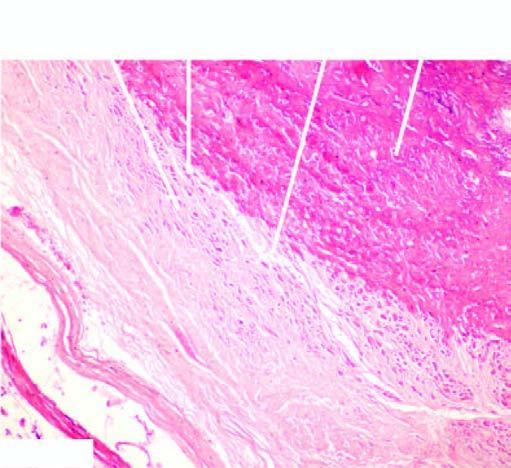what are the whorls composed of?
Answer the question using a single word or phrase. Smooth muscle cells and fibroblasts 